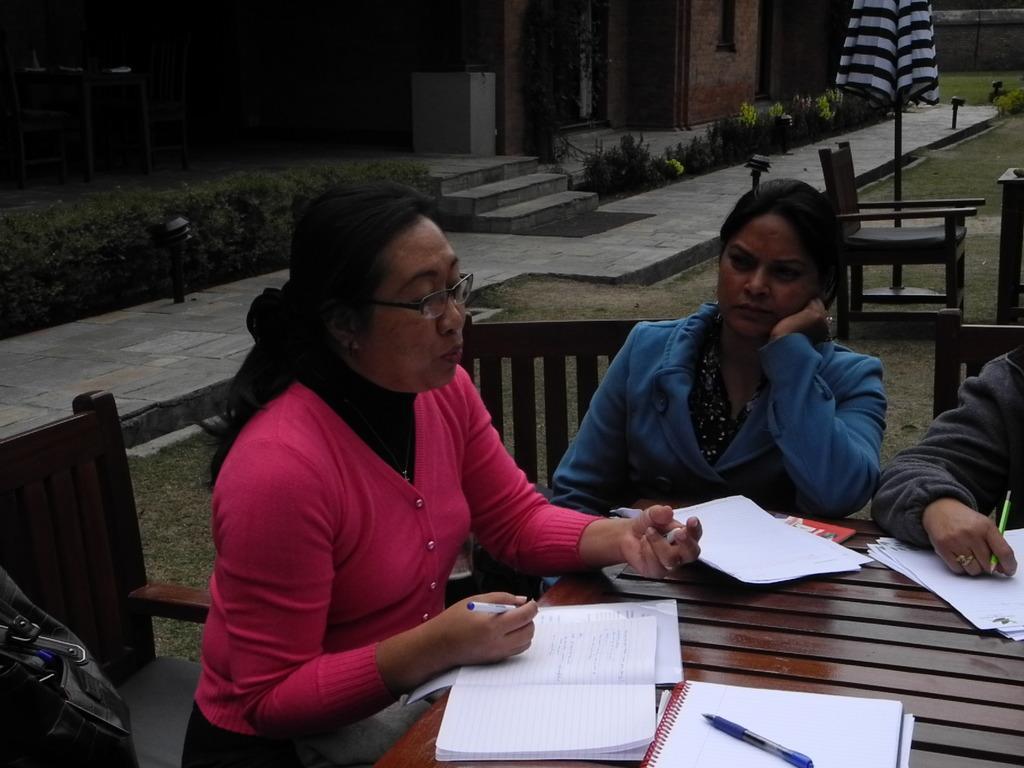In one or two sentences, can you explain what this image depicts? On the left side, there is a woman in a jacket wearing a spectacle, holding a pen, keeping her hand on a book which is on a wooden table on which there are books and documents. On the right side, there are two persons sitting on the wooden chairs in front of the table. In the background, there are plants, a chair, an umbrella, a footpath, grass, a wall and a building. 